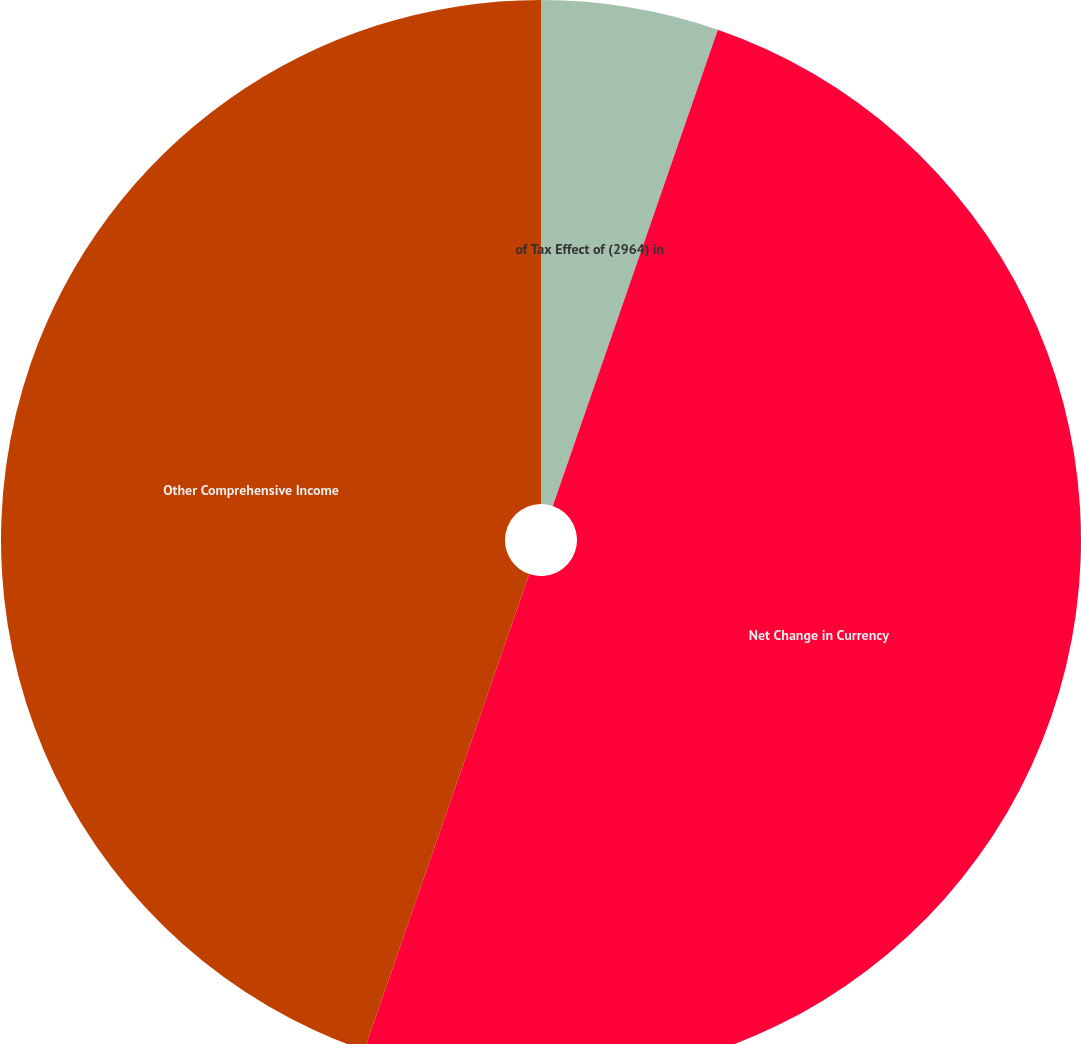Convert chart to OTSL. <chart><loc_0><loc_0><loc_500><loc_500><pie_chart><fcel>of Tax Effect of (2964) in<fcel>Net Change in Currency<fcel>Other Comprehensive Income<nl><fcel>5.31%<fcel>50.0%<fcel>44.69%<nl></chart> 